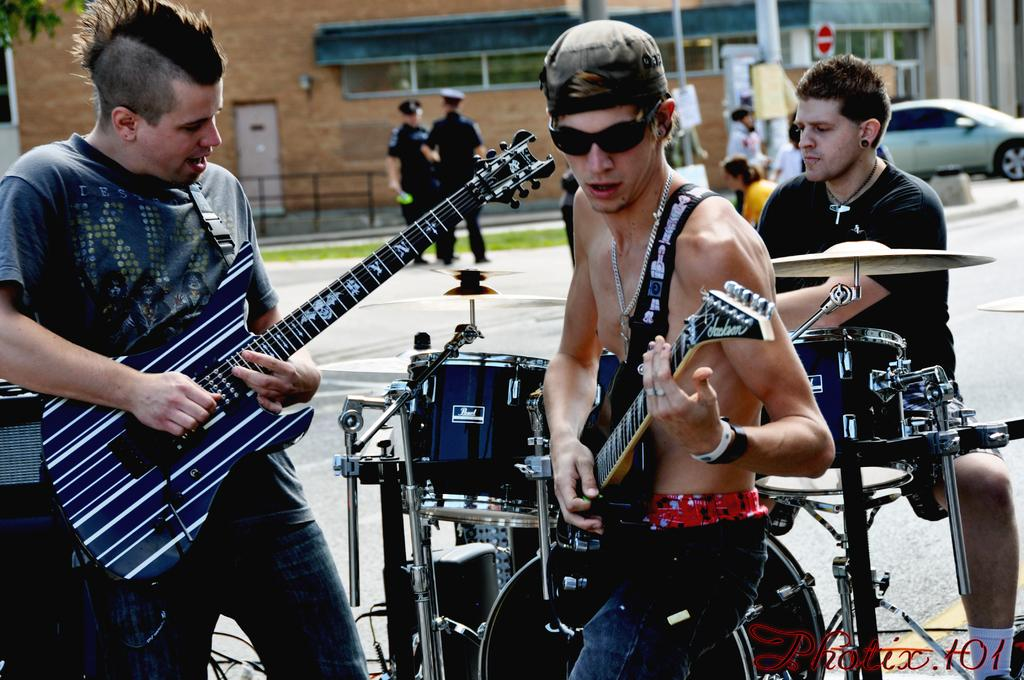How many people are in the image? There are three persons in the image. What are the persons doing in the image? The persons are playing musical instruments. What can be seen in the background of the image? There is a building and a car in the background of the image. Who is the owner of the finger in the image? There is no finger mentioned or visible in the image. 